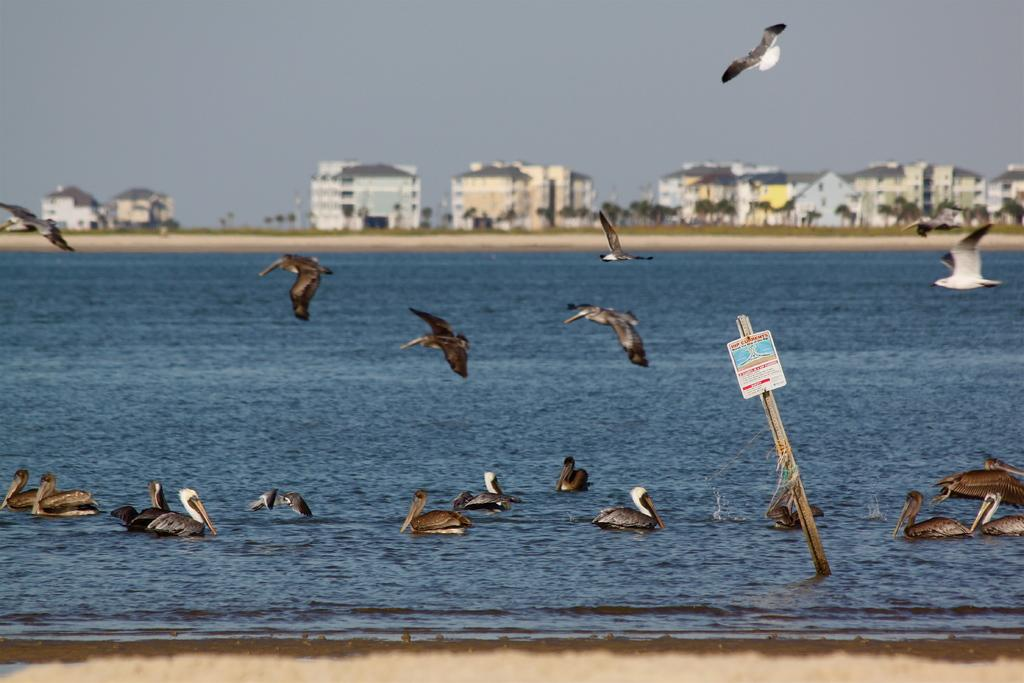What type of animals can be seen in the image? There are birds in the image, specifically swans. What is located at the bottom of the image? There is water at the bottom of the image. What can be seen in the background of the image? There are buildings and trees in the background of the image. What is present on the right side of the image? There is a board on the right side of the image. What type of waste can be seen in the image? There is no waste present in the image. What type of stew is being prepared by the swans in the image? There is no stew or cooking activity depicted in the image; the swans are simply swimming in the water. 